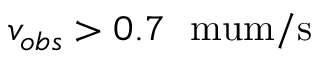<formula> <loc_0><loc_0><loc_500><loc_500>v _ { o b s } > 0 . 7 \ \ m u m / s</formula> 